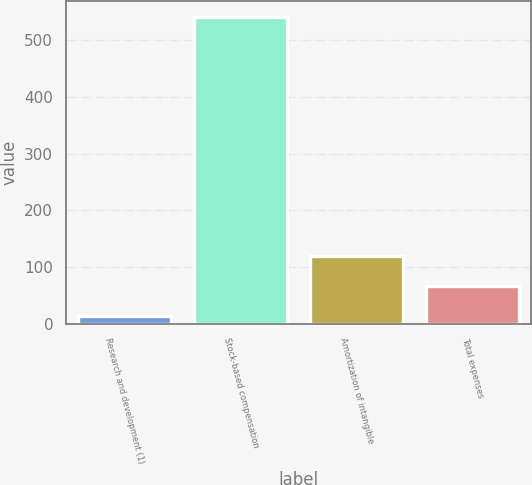Convert chart to OTSL. <chart><loc_0><loc_0><loc_500><loc_500><bar_chart><fcel>Research and development (1)<fcel>Stock-based compensation<fcel>Amortization of intangible<fcel>Total expenses<nl><fcel>14<fcel>541<fcel>119.4<fcel>66.7<nl></chart> 